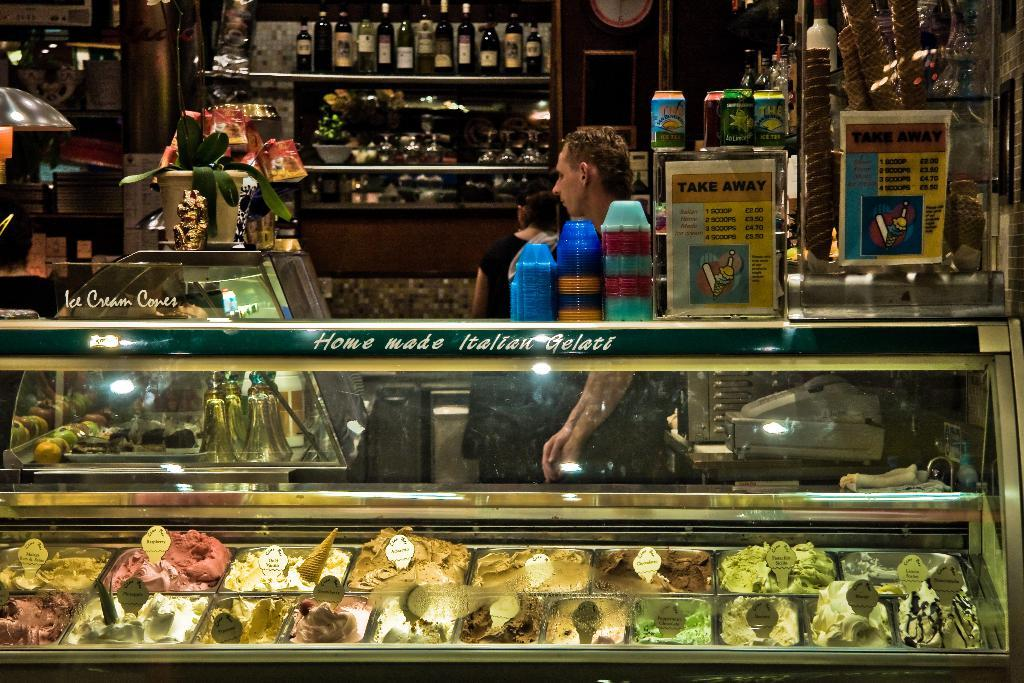What type of establishment is shown in the image? There is a store in the image. What items can be seen on display in the store? Wine bottles are placed on a shelf in the store. What type of food items are stored in the fridge in the store? Pastries and cakes are placed in a fridge in the store. Can you describe any decorative elements in the store? There is a flower pot on a table in the store. What direction is the store facing in the image? The direction the store is facing cannot be determined from the image. Are there any plastic items visible in the image? There is no mention of plastic items in the provided facts, so it cannot be determined if any are present in the image. 